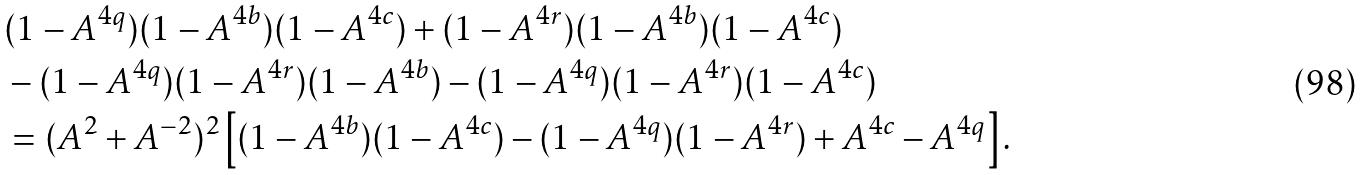<formula> <loc_0><loc_0><loc_500><loc_500>& ( 1 - A ^ { 4 q } ) ( 1 - A ^ { 4 b } ) ( 1 - A ^ { 4 c } ) + ( 1 - A ^ { 4 r } ) ( 1 - A ^ { 4 b } ) ( 1 - A ^ { 4 c } ) \\ & - ( 1 - A ^ { 4 q } ) ( 1 - A ^ { 4 r } ) ( 1 - A ^ { 4 b } ) - ( 1 - A ^ { 4 q } ) ( 1 - A ^ { 4 r } ) ( 1 - A ^ { 4 c } ) \\ & = ( A ^ { 2 } + A ^ { - 2 } ) ^ { 2 } \left [ ( 1 - A ^ { 4 b } ) ( 1 - A ^ { 4 c } ) - ( 1 - A ^ { 4 q } ) ( 1 - A ^ { 4 r } ) + A ^ { 4 c } - A ^ { 4 q } \right ] .</formula> 